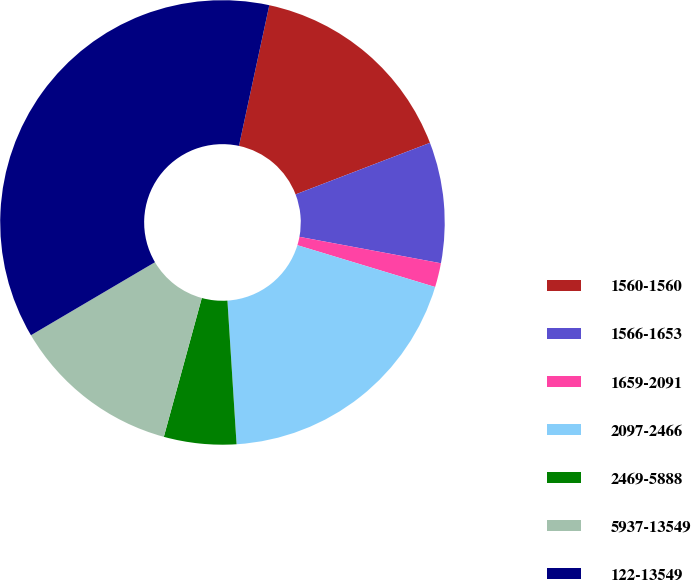<chart> <loc_0><loc_0><loc_500><loc_500><pie_chart><fcel>1560-1560<fcel>1566-1653<fcel>1659-2091<fcel>2097-2466<fcel>2469-5888<fcel>5937-13549<fcel>122-13549<nl><fcel>15.79%<fcel>8.77%<fcel>1.75%<fcel>19.3%<fcel>5.26%<fcel>12.28%<fcel>36.85%<nl></chart> 